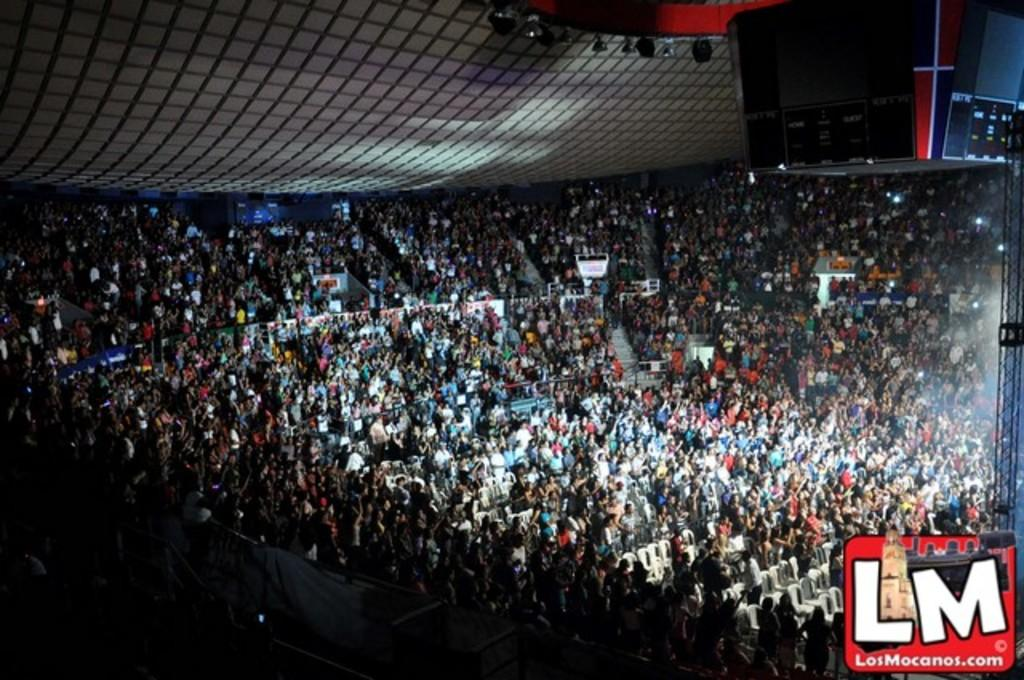What type of structure is shown in the image? There is a stadium in the image. What can be seen inside the stadium? There is a crowd in the stadium. What feature is visible on top of the stadium? There is a roof visible in the image. Can you describe the stand on the right side of the image? There is a stand on the right side of the image. How many babies are participating in the war depicted in the image? There is no war or babies present in the image; it features a stadium with a crowd and a stand. 